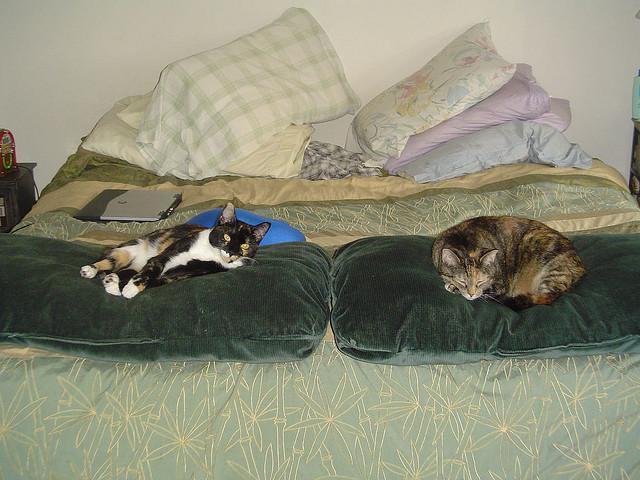How many cats are on pillows?
Indicate the correct choice and explain in the format: 'Answer: answer
Rationale: rationale.'
Options: Two, six, eight, four. Answer: two.
Rationale: There is a calico cat on one pillow and a tabby cat on the other pillow. 